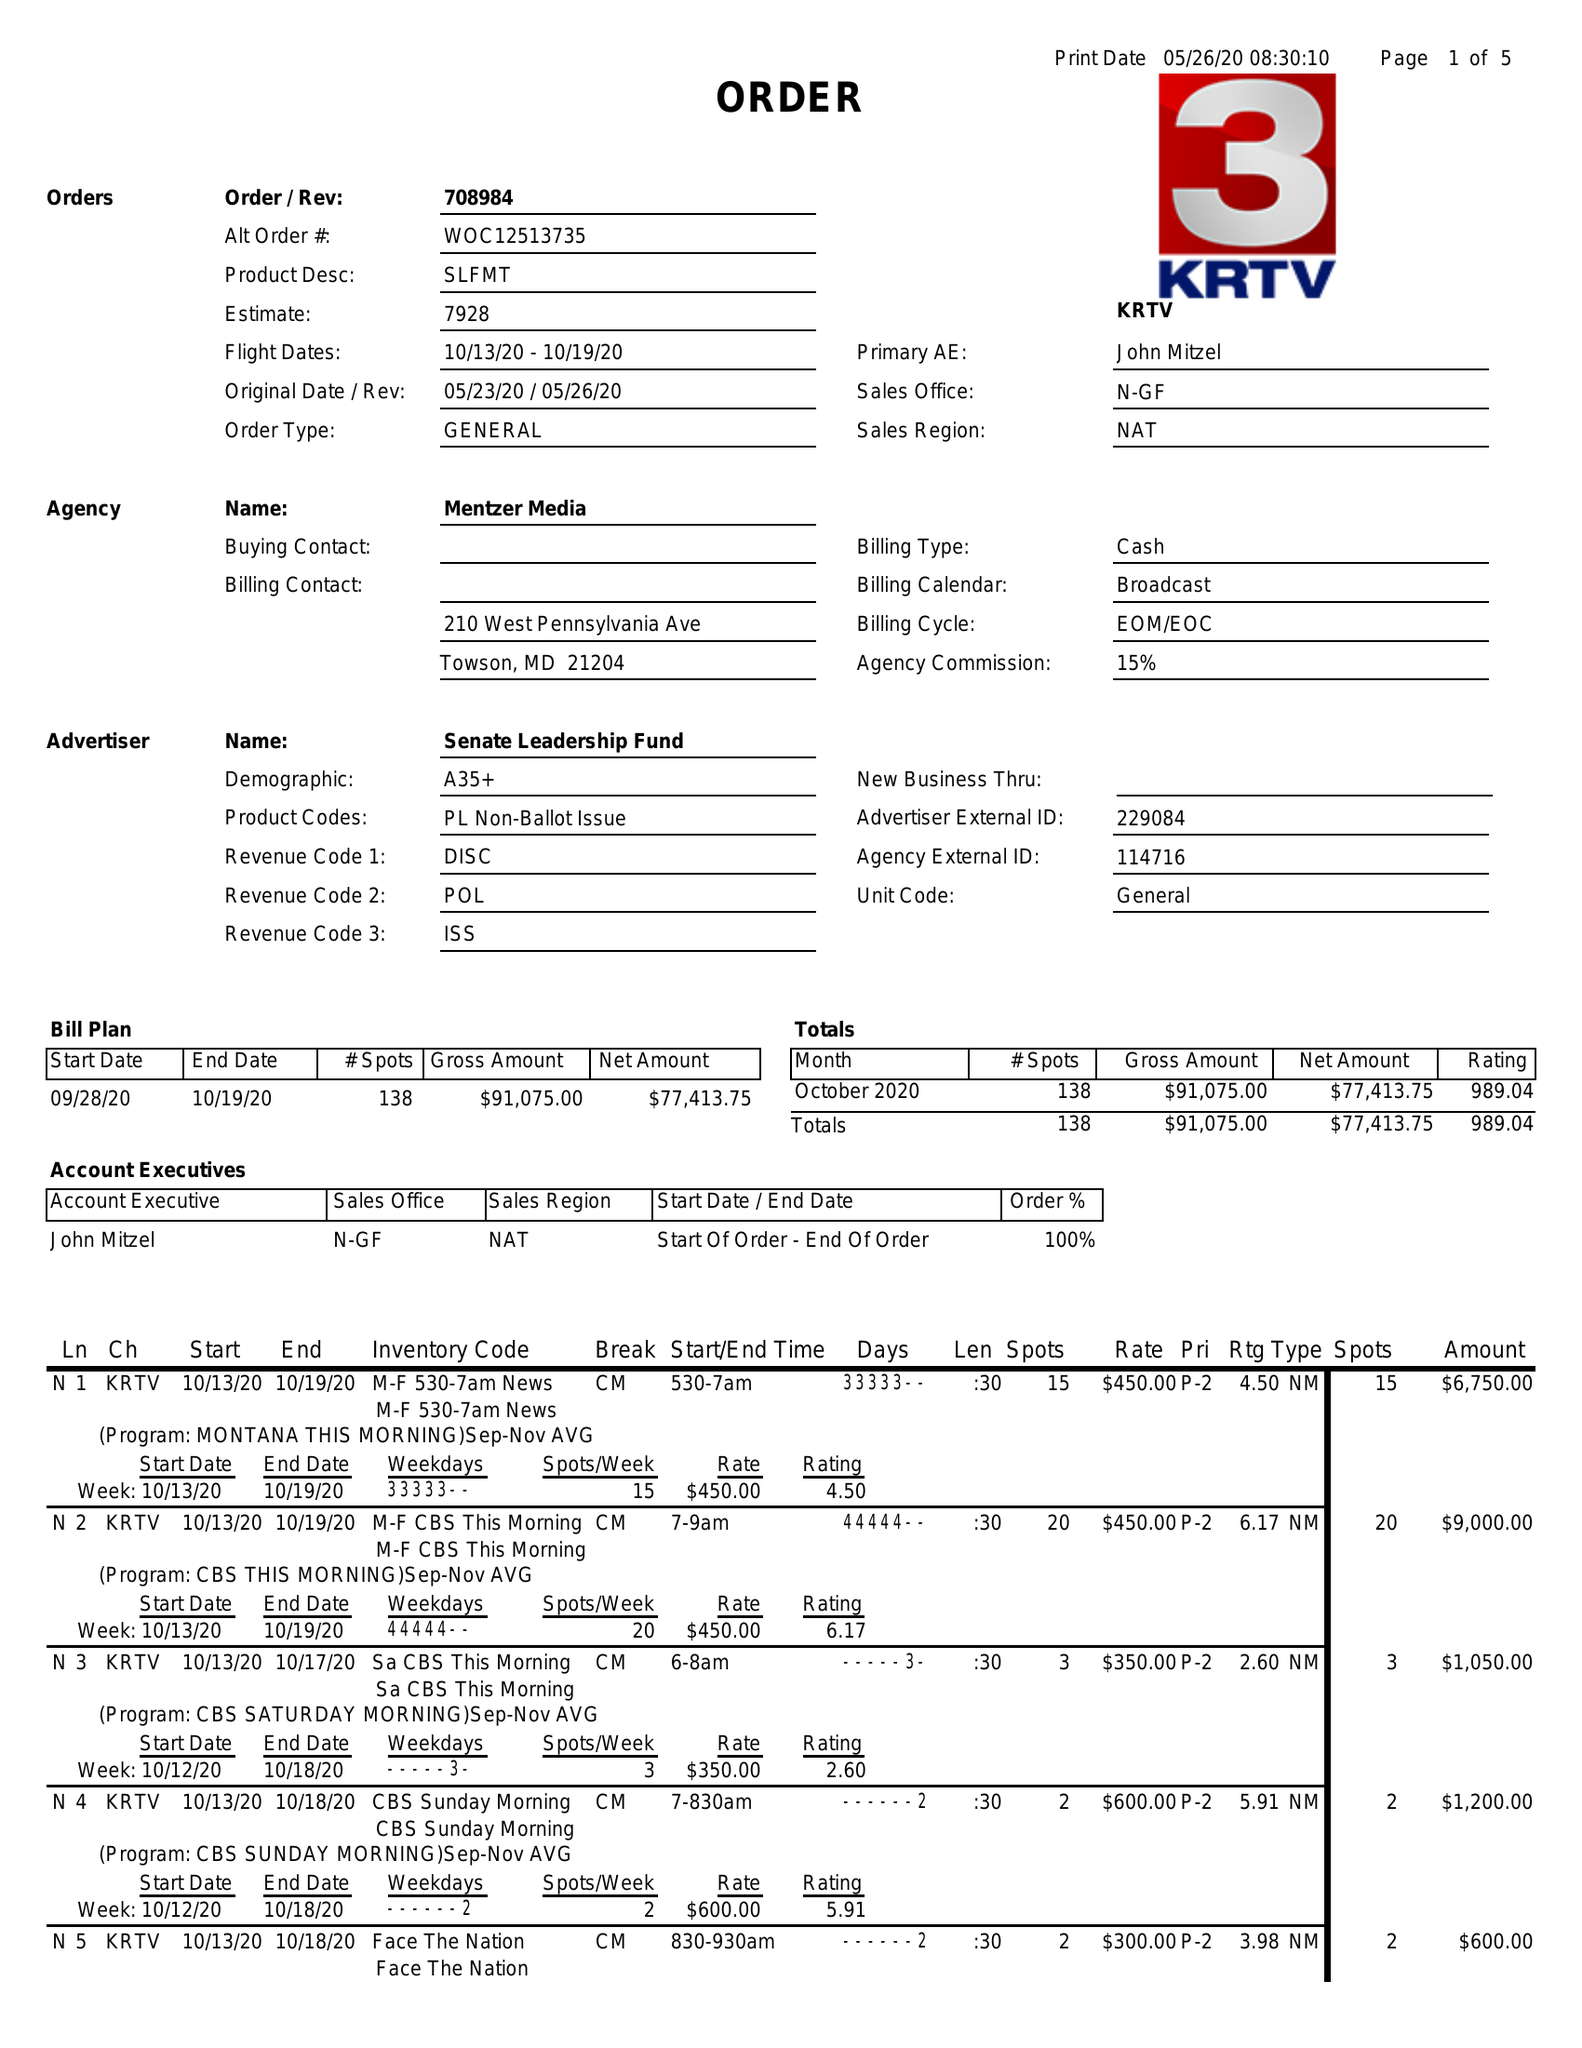What is the value for the contract_num?
Answer the question using a single word or phrase. 708984 